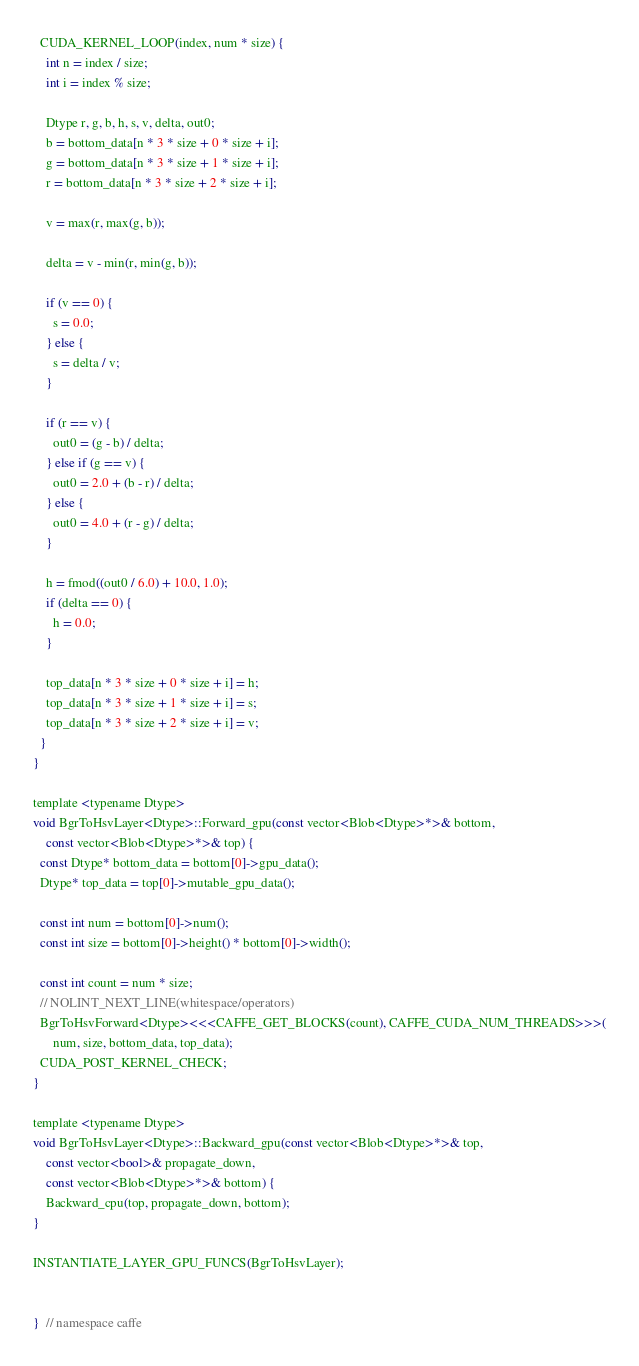<code> <loc_0><loc_0><loc_500><loc_500><_Cuda_>  CUDA_KERNEL_LOOP(index, num * size) {
    int n = index / size;
    int i = index % size;

    Dtype r, g, b, h, s, v, delta, out0;
    b = bottom_data[n * 3 * size + 0 * size + i];
    g = bottom_data[n * 3 * size + 1 * size + i];
    r = bottom_data[n * 3 * size + 2 * size + i];

    v = max(r, max(g, b));

    delta = v - min(r, min(g, b));

    if (v == 0) {
      s = 0.0;
    } else {
      s = delta / v;
    }

    if (r == v) {
      out0 = (g - b) / delta;
    } else if (g == v) {
      out0 = 2.0 + (b - r) / delta;
    } else {
      out0 = 4.0 + (r - g) / delta;
    }

    h = fmod((out0 / 6.0) + 10.0, 1.0);
    if (delta == 0) {
      h = 0.0;
    }

    top_data[n * 3 * size + 0 * size + i] = h;
    top_data[n * 3 * size + 1 * size + i] = s;
    top_data[n * 3 * size + 2 * size + i] = v;
  }
}

template <typename Dtype>
void BgrToHsvLayer<Dtype>::Forward_gpu(const vector<Blob<Dtype>*>& bottom,
    const vector<Blob<Dtype>*>& top) {
  const Dtype* bottom_data = bottom[0]->gpu_data();
  Dtype* top_data = top[0]->mutable_gpu_data();

  const int num = bottom[0]->num();
  const int size = bottom[0]->height() * bottom[0]->width();

  const int count = num * size;
  // NOLINT_NEXT_LINE(whitespace/operators)
  BgrToHsvForward<Dtype><<<CAFFE_GET_BLOCKS(count), CAFFE_CUDA_NUM_THREADS>>>(
      num, size, bottom_data, top_data);
  CUDA_POST_KERNEL_CHECK;
}

template <typename Dtype>
void BgrToHsvLayer<Dtype>::Backward_gpu(const vector<Blob<Dtype>*>& top,
    const vector<bool>& propagate_down,
    const vector<Blob<Dtype>*>& bottom) {
    Backward_cpu(top, propagate_down, bottom);
}

INSTANTIATE_LAYER_GPU_FUNCS(BgrToHsvLayer);


}  // namespace caffe

</code> 